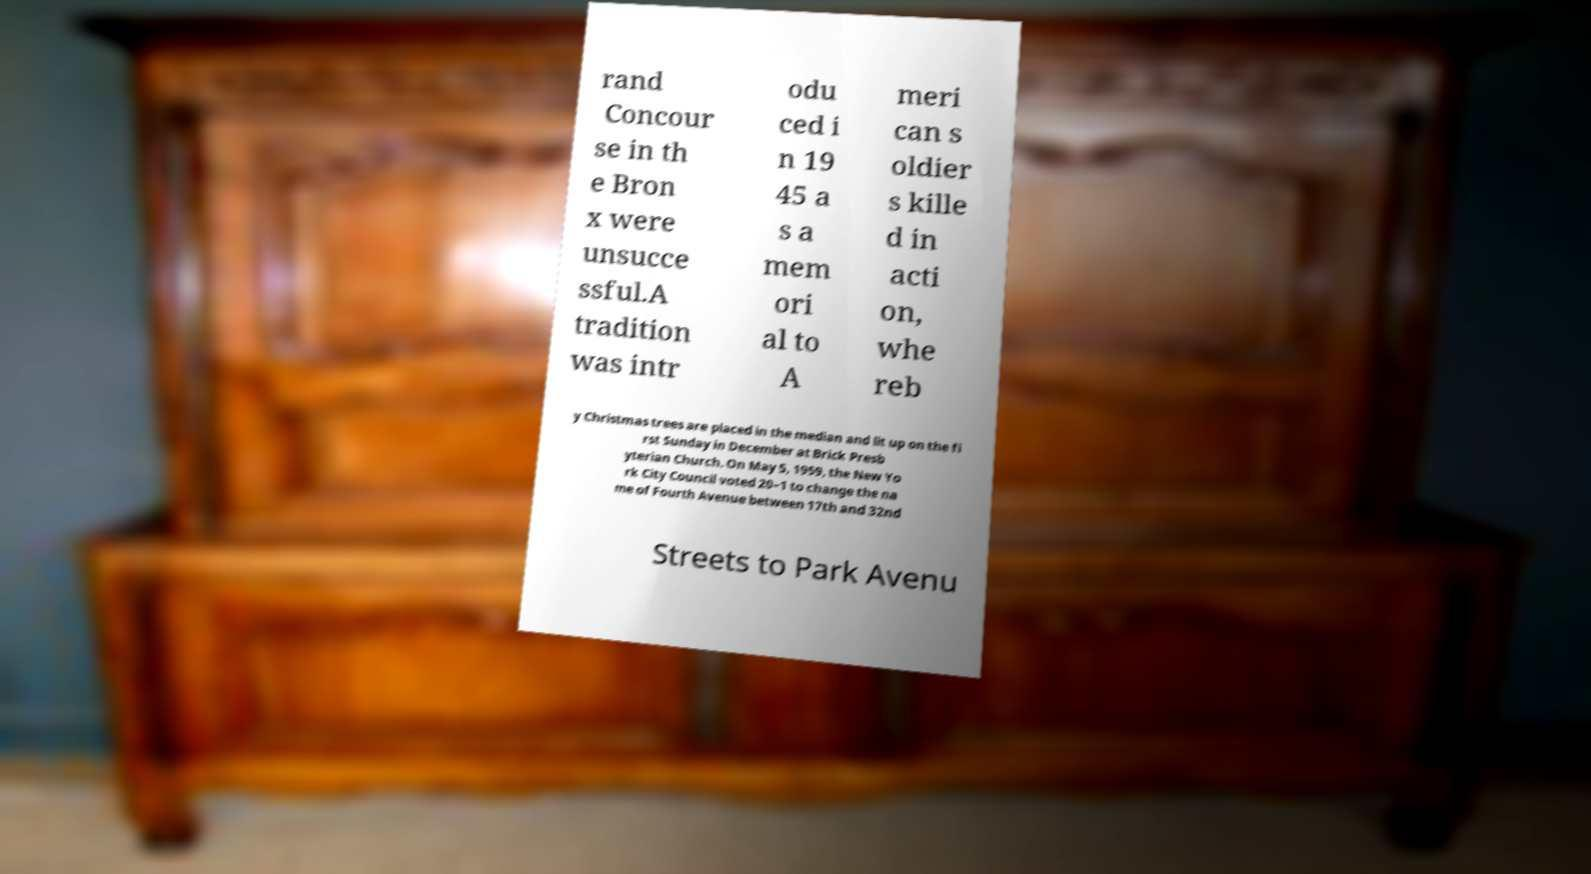Can you accurately transcribe the text from the provided image for me? rand Concour se in th e Bron x were unsucce ssful.A tradition was intr odu ced i n 19 45 a s a mem ori al to A meri can s oldier s kille d in acti on, whe reb y Christmas trees are placed in the median and lit up on the fi rst Sunday in December at Brick Presb yterian Church. On May 5, 1959, the New Yo rk City Council voted 20–1 to change the na me of Fourth Avenue between 17th and 32nd Streets to Park Avenu 